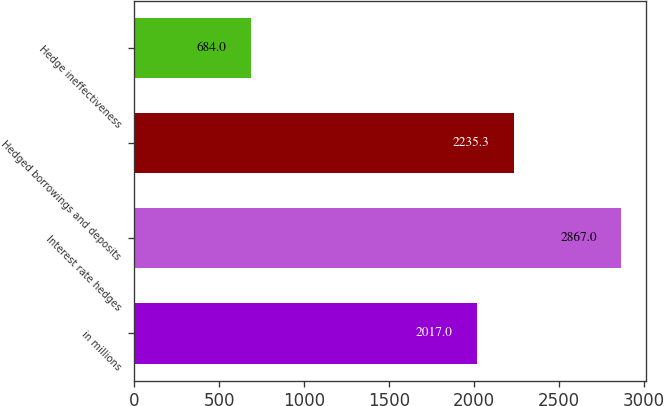Convert chart to OTSL. <chart><loc_0><loc_0><loc_500><loc_500><bar_chart><fcel>in millions<fcel>Interest rate hedges<fcel>Hedged borrowings and deposits<fcel>Hedge ineffectiveness<nl><fcel>2017<fcel>2867<fcel>2235.3<fcel>684<nl></chart> 